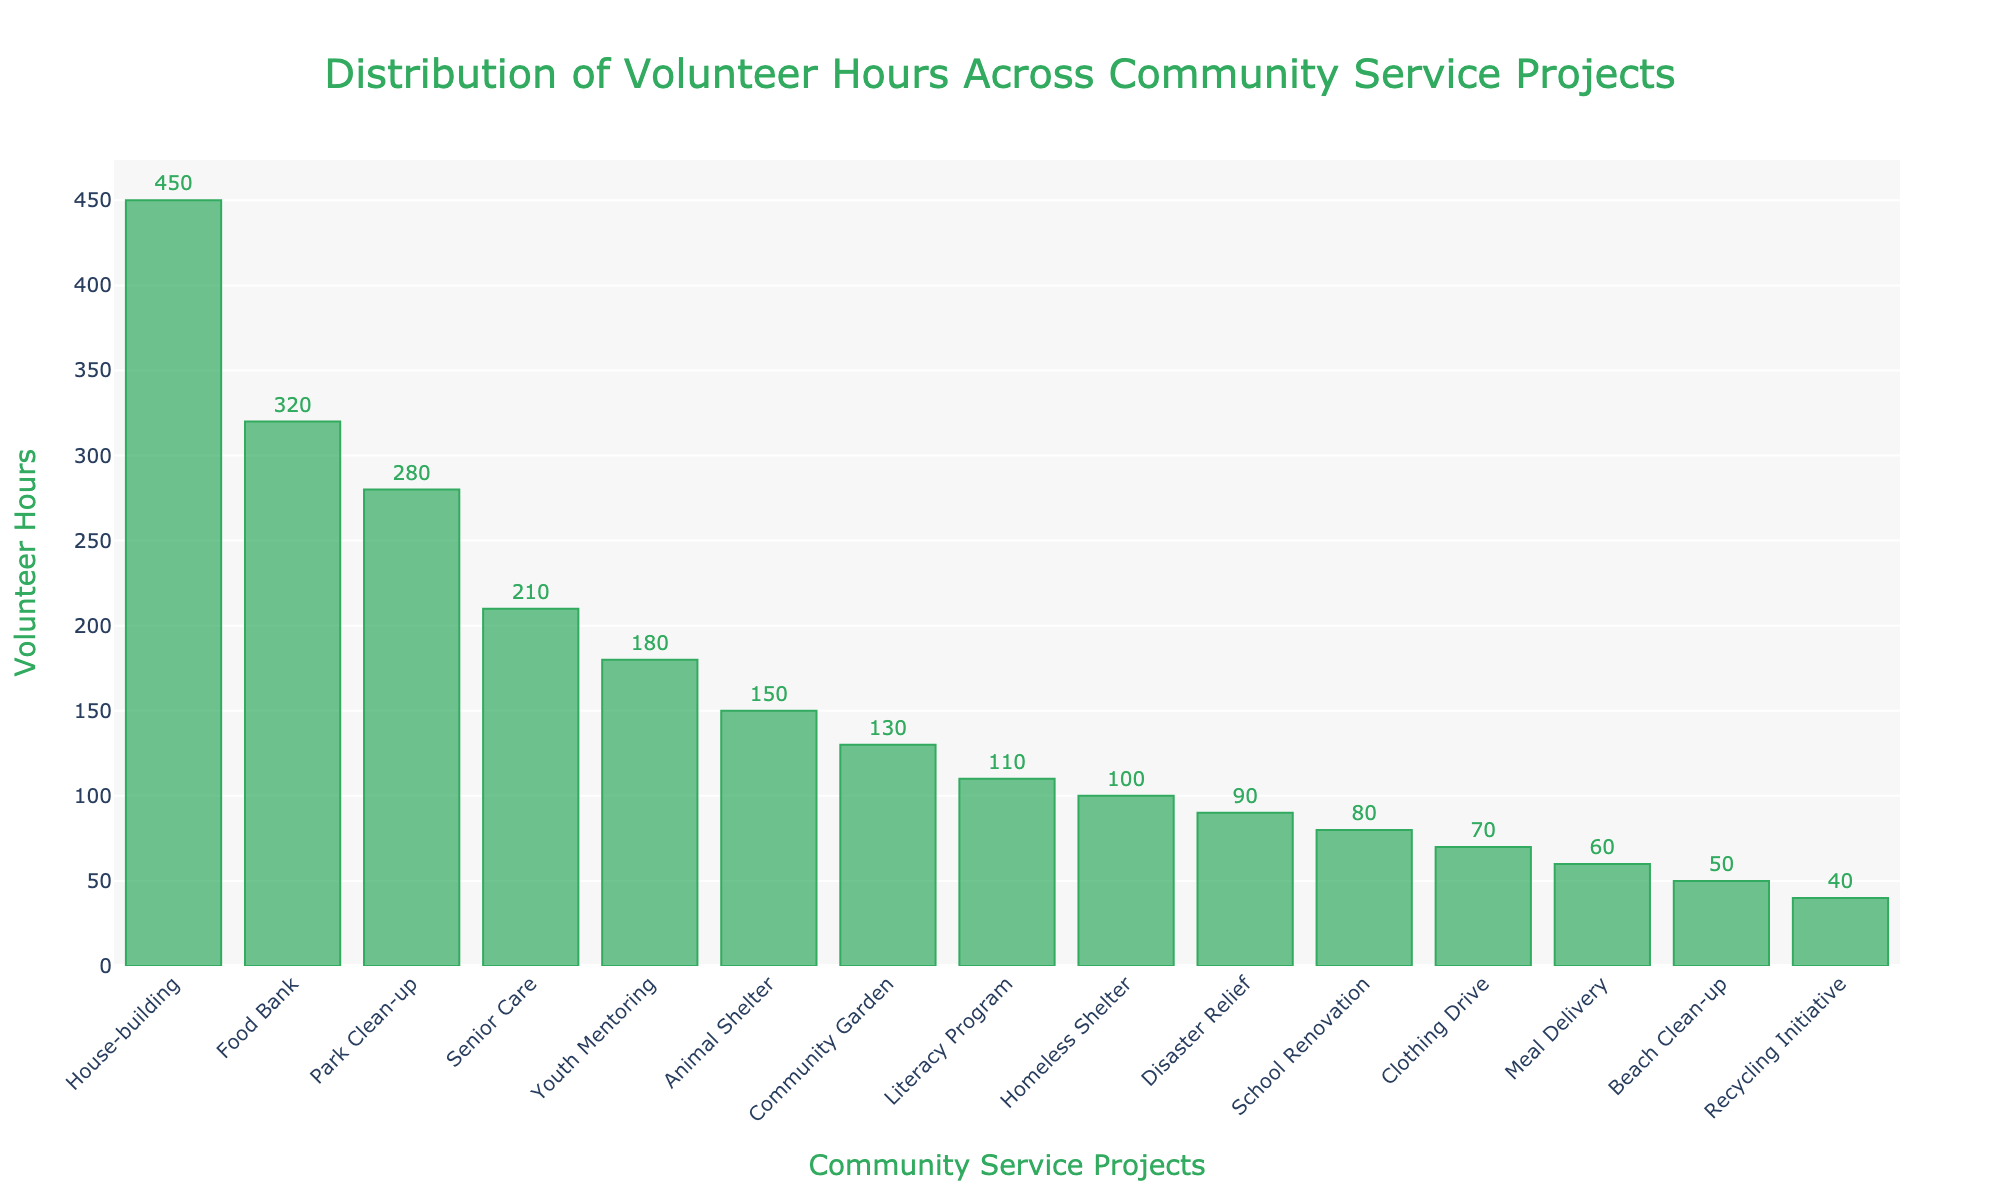Which community service project received the most volunteer hours? From the figure, the "House-building" project has the highest bar, indicating it received the most volunteer hours.
Answer: House-building How many more volunteer hours did House-building receive compared to Food Bank? The figure shows House-building received 450 hours and Food Bank received 320 hours. Subtracting these gives 450 - 320 = 130 hours more.
Answer: 130 Which is the least volunteered project? The project with the shortest bar in the chart is the "Recycling Initiative," indicating it received the fewest volunteer hours.
Answer: Recycling Initiative How many total volunteer hours were dedicated to Park Clean-up and Senior Care together? From the figure, Park Clean-up has 280 hours and Senior Care has 210 hours. Adding these gives 280 + 210 = 490 hours total.
Answer: 490 Are there more hours dedicated to Youth Mentoring or Animal Shelter? The figure shows that Youth Mentoring has 180 hours and Animal Shelter has 150 hours. Youth Mentoring has more hours.
Answer: Youth Mentoring How many projects have volunteer hours greater than 200? By observing the figure, four projects have bars extending beyond the 200-hour mark: House-building, Food Bank, Park Clean-up, and Senior Care.
Answer: 4 What is the sum of volunteer hours for the three least volunteered projects? The figure shows the least volunteered projects are Recycling Initiative (40 hours), Beach Clean-up (50 hours), and Meal Delivery (60 hours). Summing these gives 40 + 50 + 60 = 150 hours.
Answer: 150 Which projects received more volunteer hours than Literacy Program and less than House-building? Literacy Program has 110 hours, so projects with more hours than that and less than House-building (450 hours) are: Food Bank (320 hours), Park Clean-up (280 hours), Senior Care (210 hours), and Youth Mentoring (180 hours).
Answer: Food Bank, Park Clean-up, Senior Care, Youth Mentoring What is the average number of volunteer hours for the top five projects? The top five projects based on volunteer hours are House-building (450), Food Bank (320), Park Clean-up (280), Senior Care (210), and Youth Mentoring (180). Summing these gives 450 + 320 + 280 + 210 + 180 = 1440. The average is 1440 / 5 = 288 hours.
Answer: 288 Which project just exceeded 100 volunteer hours? From the figure, "Literacy Program" is the project with a bar that is just above the 100-hour mark, indicated by 110 volunteer hours.
Answer: Literacy Program 